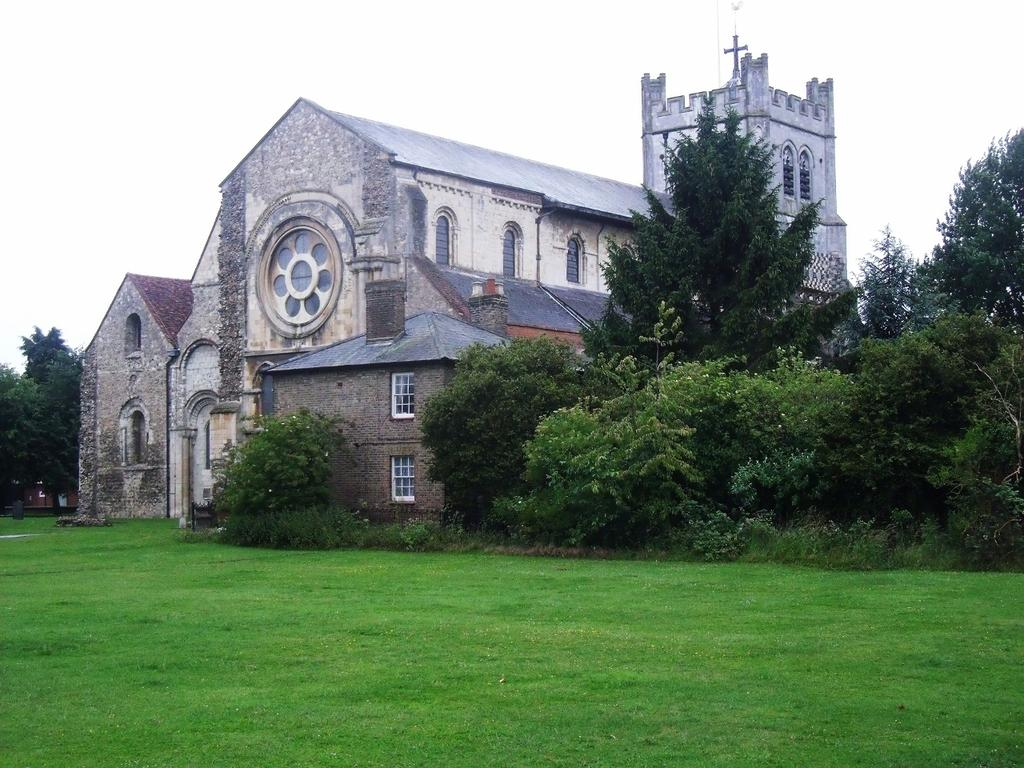What type of structure is visible in the image? There is a building in the image. What type of vegetation can be seen in the image? There are trees in the image. What covers the ground in the image? There is grass on the ground in the image. How would you describe the sky in the image? The sky is cloudy in the image. What type of disgust can be seen on the man's face in the image? There is no man present in the image, so it is not possible to answer that question. How many clovers are visible in the image? There is no mention of clovers in the provided facts, so it is not possible to answer that question. 